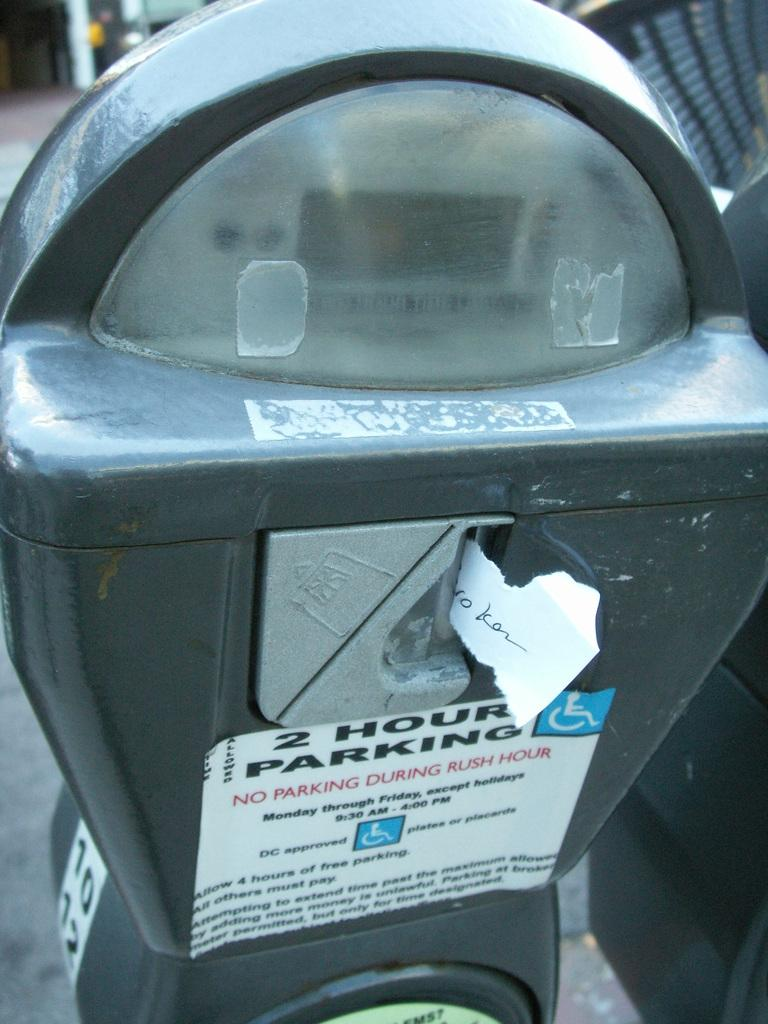<image>
Render a clear and concise summary of the photo. a parking meter states no parking during rush hour.. 